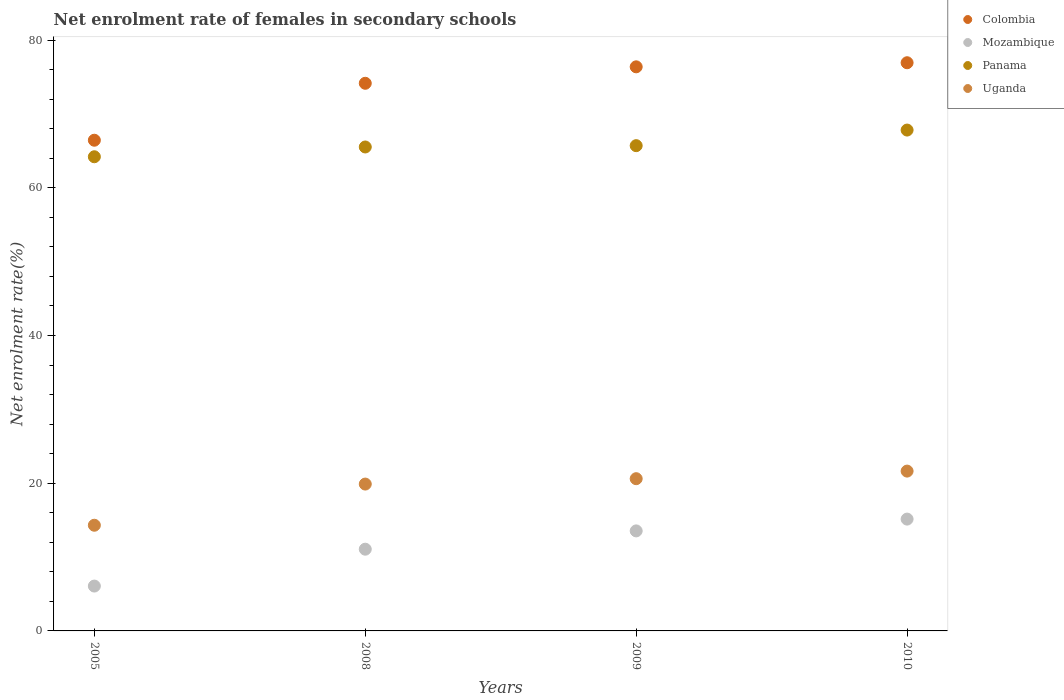How many different coloured dotlines are there?
Your answer should be compact. 4. Is the number of dotlines equal to the number of legend labels?
Offer a very short reply. Yes. What is the net enrolment rate of females in secondary schools in Panama in 2008?
Keep it short and to the point. 65.52. Across all years, what is the maximum net enrolment rate of females in secondary schools in Panama?
Your answer should be very brief. 67.81. Across all years, what is the minimum net enrolment rate of females in secondary schools in Panama?
Your response must be concise. 64.19. In which year was the net enrolment rate of females in secondary schools in Colombia maximum?
Offer a terse response. 2010. In which year was the net enrolment rate of females in secondary schools in Uganda minimum?
Make the answer very short. 2005. What is the total net enrolment rate of females in secondary schools in Mozambique in the graph?
Your answer should be very brief. 45.82. What is the difference between the net enrolment rate of females in secondary schools in Panama in 2005 and that in 2010?
Offer a very short reply. -3.61. What is the difference between the net enrolment rate of females in secondary schools in Colombia in 2009 and the net enrolment rate of females in secondary schools in Panama in 2010?
Your answer should be compact. 8.56. What is the average net enrolment rate of females in secondary schools in Colombia per year?
Provide a short and direct response. 73.47. In the year 2010, what is the difference between the net enrolment rate of females in secondary schools in Mozambique and net enrolment rate of females in secondary schools in Panama?
Ensure brevity in your answer.  -52.67. In how many years, is the net enrolment rate of females in secondary schools in Panama greater than 48 %?
Provide a short and direct response. 4. What is the ratio of the net enrolment rate of females in secondary schools in Panama in 2008 to that in 2010?
Your answer should be compact. 0.97. Is the net enrolment rate of females in secondary schools in Colombia in 2008 less than that in 2009?
Your answer should be compact. Yes. What is the difference between the highest and the second highest net enrolment rate of females in secondary schools in Colombia?
Give a very brief answer. 0.55. What is the difference between the highest and the lowest net enrolment rate of females in secondary schools in Panama?
Your answer should be very brief. 3.61. Is the sum of the net enrolment rate of females in secondary schools in Panama in 2008 and 2009 greater than the maximum net enrolment rate of females in secondary schools in Mozambique across all years?
Your answer should be very brief. Yes. Is it the case that in every year, the sum of the net enrolment rate of females in secondary schools in Uganda and net enrolment rate of females in secondary schools in Panama  is greater than the sum of net enrolment rate of females in secondary schools in Mozambique and net enrolment rate of females in secondary schools in Colombia?
Give a very brief answer. No. Does the net enrolment rate of females in secondary schools in Mozambique monotonically increase over the years?
Offer a terse response. Yes. Is the net enrolment rate of females in secondary schools in Mozambique strictly greater than the net enrolment rate of females in secondary schools in Panama over the years?
Give a very brief answer. No. Is the net enrolment rate of females in secondary schools in Panama strictly less than the net enrolment rate of females in secondary schools in Mozambique over the years?
Offer a terse response. No. How many dotlines are there?
Offer a terse response. 4. How many years are there in the graph?
Keep it short and to the point. 4. Does the graph contain grids?
Make the answer very short. No. How many legend labels are there?
Provide a succinct answer. 4. How are the legend labels stacked?
Your answer should be very brief. Vertical. What is the title of the graph?
Keep it short and to the point. Net enrolment rate of females in secondary schools. What is the label or title of the Y-axis?
Provide a short and direct response. Net enrolment rate(%). What is the Net enrolment rate(%) in Colombia in 2005?
Ensure brevity in your answer.  66.43. What is the Net enrolment rate(%) in Mozambique in 2005?
Keep it short and to the point. 6.07. What is the Net enrolment rate(%) in Panama in 2005?
Give a very brief answer. 64.19. What is the Net enrolment rate(%) of Uganda in 2005?
Your response must be concise. 14.31. What is the Net enrolment rate(%) of Colombia in 2008?
Offer a terse response. 74.14. What is the Net enrolment rate(%) in Mozambique in 2008?
Your answer should be very brief. 11.06. What is the Net enrolment rate(%) of Panama in 2008?
Your response must be concise. 65.52. What is the Net enrolment rate(%) in Uganda in 2008?
Offer a terse response. 19.88. What is the Net enrolment rate(%) in Colombia in 2009?
Offer a very short reply. 76.37. What is the Net enrolment rate(%) in Mozambique in 2009?
Offer a terse response. 13.54. What is the Net enrolment rate(%) of Panama in 2009?
Your answer should be compact. 65.7. What is the Net enrolment rate(%) in Uganda in 2009?
Give a very brief answer. 20.61. What is the Net enrolment rate(%) of Colombia in 2010?
Make the answer very short. 76.92. What is the Net enrolment rate(%) of Mozambique in 2010?
Keep it short and to the point. 15.14. What is the Net enrolment rate(%) of Panama in 2010?
Your answer should be very brief. 67.81. What is the Net enrolment rate(%) in Uganda in 2010?
Ensure brevity in your answer.  21.64. Across all years, what is the maximum Net enrolment rate(%) in Colombia?
Ensure brevity in your answer.  76.92. Across all years, what is the maximum Net enrolment rate(%) in Mozambique?
Offer a terse response. 15.14. Across all years, what is the maximum Net enrolment rate(%) in Panama?
Provide a short and direct response. 67.81. Across all years, what is the maximum Net enrolment rate(%) in Uganda?
Your response must be concise. 21.64. Across all years, what is the minimum Net enrolment rate(%) in Colombia?
Offer a terse response. 66.43. Across all years, what is the minimum Net enrolment rate(%) in Mozambique?
Your answer should be very brief. 6.07. Across all years, what is the minimum Net enrolment rate(%) in Panama?
Provide a short and direct response. 64.19. Across all years, what is the minimum Net enrolment rate(%) of Uganda?
Offer a very short reply. 14.31. What is the total Net enrolment rate(%) in Colombia in the graph?
Provide a succinct answer. 293.86. What is the total Net enrolment rate(%) of Mozambique in the graph?
Your answer should be very brief. 45.82. What is the total Net enrolment rate(%) of Panama in the graph?
Make the answer very short. 263.21. What is the total Net enrolment rate(%) of Uganda in the graph?
Your response must be concise. 76.43. What is the difference between the Net enrolment rate(%) in Colombia in 2005 and that in 2008?
Your answer should be compact. -7.71. What is the difference between the Net enrolment rate(%) in Mozambique in 2005 and that in 2008?
Ensure brevity in your answer.  -4.99. What is the difference between the Net enrolment rate(%) in Panama in 2005 and that in 2008?
Make the answer very short. -1.32. What is the difference between the Net enrolment rate(%) of Uganda in 2005 and that in 2008?
Give a very brief answer. -5.57. What is the difference between the Net enrolment rate(%) of Colombia in 2005 and that in 2009?
Your answer should be very brief. -9.94. What is the difference between the Net enrolment rate(%) in Mozambique in 2005 and that in 2009?
Keep it short and to the point. -7.47. What is the difference between the Net enrolment rate(%) in Panama in 2005 and that in 2009?
Ensure brevity in your answer.  -1.5. What is the difference between the Net enrolment rate(%) in Uganda in 2005 and that in 2009?
Provide a succinct answer. -6.3. What is the difference between the Net enrolment rate(%) of Colombia in 2005 and that in 2010?
Offer a terse response. -10.49. What is the difference between the Net enrolment rate(%) in Mozambique in 2005 and that in 2010?
Ensure brevity in your answer.  -9.07. What is the difference between the Net enrolment rate(%) of Panama in 2005 and that in 2010?
Ensure brevity in your answer.  -3.61. What is the difference between the Net enrolment rate(%) in Uganda in 2005 and that in 2010?
Offer a terse response. -7.33. What is the difference between the Net enrolment rate(%) of Colombia in 2008 and that in 2009?
Keep it short and to the point. -2.23. What is the difference between the Net enrolment rate(%) of Mozambique in 2008 and that in 2009?
Keep it short and to the point. -2.48. What is the difference between the Net enrolment rate(%) of Panama in 2008 and that in 2009?
Your response must be concise. -0.18. What is the difference between the Net enrolment rate(%) in Uganda in 2008 and that in 2009?
Provide a succinct answer. -0.73. What is the difference between the Net enrolment rate(%) of Colombia in 2008 and that in 2010?
Keep it short and to the point. -2.78. What is the difference between the Net enrolment rate(%) of Mozambique in 2008 and that in 2010?
Your answer should be very brief. -4.07. What is the difference between the Net enrolment rate(%) in Panama in 2008 and that in 2010?
Give a very brief answer. -2.29. What is the difference between the Net enrolment rate(%) of Uganda in 2008 and that in 2010?
Your answer should be compact. -1.75. What is the difference between the Net enrolment rate(%) of Colombia in 2009 and that in 2010?
Offer a very short reply. -0.55. What is the difference between the Net enrolment rate(%) in Mozambique in 2009 and that in 2010?
Offer a terse response. -1.6. What is the difference between the Net enrolment rate(%) of Panama in 2009 and that in 2010?
Your answer should be compact. -2.11. What is the difference between the Net enrolment rate(%) in Uganda in 2009 and that in 2010?
Provide a short and direct response. -1.03. What is the difference between the Net enrolment rate(%) in Colombia in 2005 and the Net enrolment rate(%) in Mozambique in 2008?
Your answer should be very brief. 55.37. What is the difference between the Net enrolment rate(%) of Colombia in 2005 and the Net enrolment rate(%) of Panama in 2008?
Provide a short and direct response. 0.92. What is the difference between the Net enrolment rate(%) in Colombia in 2005 and the Net enrolment rate(%) in Uganda in 2008?
Make the answer very short. 46.55. What is the difference between the Net enrolment rate(%) in Mozambique in 2005 and the Net enrolment rate(%) in Panama in 2008?
Make the answer very short. -59.44. What is the difference between the Net enrolment rate(%) in Mozambique in 2005 and the Net enrolment rate(%) in Uganda in 2008?
Offer a very short reply. -13.81. What is the difference between the Net enrolment rate(%) of Panama in 2005 and the Net enrolment rate(%) of Uganda in 2008?
Your answer should be very brief. 44.31. What is the difference between the Net enrolment rate(%) in Colombia in 2005 and the Net enrolment rate(%) in Mozambique in 2009?
Your response must be concise. 52.89. What is the difference between the Net enrolment rate(%) of Colombia in 2005 and the Net enrolment rate(%) of Panama in 2009?
Make the answer very short. 0.74. What is the difference between the Net enrolment rate(%) in Colombia in 2005 and the Net enrolment rate(%) in Uganda in 2009?
Your answer should be very brief. 45.82. What is the difference between the Net enrolment rate(%) of Mozambique in 2005 and the Net enrolment rate(%) of Panama in 2009?
Your answer should be compact. -59.62. What is the difference between the Net enrolment rate(%) of Mozambique in 2005 and the Net enrolment rate(%) of Uganda in 2009?
Provide a succinct answer. -14.54. What is the difference between the Net enrolment rate(%) of Panama in 2005 and the Net enrolment rate(%) of Uganda in 2009?
Your answer should be compact. 43.58. What is the difference between the Net enrolment rate(%) in Colombia in 2005 and the Net enrolment rate(%) in Mozambique in 2010?
Keep it short and to the point. 51.29. What is the difference between the Net enrolment rate(%) in Colombia in 2005 and the Net enrolment rate(%) in Panama in 2010?
Make the answer very short. -1.38. What is the difference between the Net enrolment rate(%) of Colombia in 2005 and the Net enrolment rate(%) of Uganda in 2010?
Offer a very short reply. 44.8. What is the difference between the Net enrolment rate(%) of Mozambique in 2005 and the Net enrolment rate(%) of Panama in 2010?
Keep it short and to the point. -61.73. What is the difference between the Net enrolment rate(%) in Mozambique in 2005 and the Net enrolment rate(%) in Uganda in 2010?
Your response must be concise. -15.56. What is the difference between the Net enrolment rate(%) in Panama in 2005 and the Net enrolment rate(%) in Uganda in 2010?
Your answer should be very brief. 42.56. What is the difference between the Net enrolment rate(%) in Colombia in 2008 and the Net enrolment rate(%) in Mozambique in 2009?
Provide a succinct answer. 60.6. What is the difference between the Net enrolment rate(%) in Colombia in 2008 and the Net enrolment rate(%) in Panama in 2009?
Offer a very short reply. 8.44. What is the difference between the Net enrolment rate(%) in Colombia in 2008 and the Net enrolment rate(%) in Uganda in 2009?
Offer a very short reply. 53.53. What is the difference between the Net enrolment rate(%) in Mozambique in 2008 and the Net enrolment rate(%) in Panama in 2009?
Offer a very short reply. -54.63. What is the difference between the Net enrolment rate(%) of Mozambique in 2008 and the Net enrolment rate(%) of Uganda in 2009?
Offer a terse response. -9.54. What is the difference between the Net enrolment rate(%) of Panama in 2008 and the Net enrolment rate(%) of Uganda in 2009?
Provide a short and direct response. 44.91. What is the difference between the Net enrolment rate(%) in Colombia in 2008 and the Net enrolment rate(%) in Mozambique in 2010?
Ensure brevity in your answer.  59. What is the difference between the Net enrolment rate(%) in Colombia in 2008 and the Net enrolment rate(%) in Panama in 2010?
Your response must be concise. 6.33. What is the difference between the Net enrolment rate(%) of Colombia in 2008 and the Net enrolment rate(%) of Uganda in 2010?
Keep it short and to the point. 52.5. What is the difference between the Net enrolment rate(%) of Mozambique in 2008 and the Net enrolment rate(%) of Panama in 2010?
Give a very brief answer. -56.74. What is the difference between the Net enrolment rate(%) of Mozambique in 2008 and the Net enrolment rate(%) of Uganda in 2010?
Offer a very short reply. -10.57. What is the difference between the Net enrolment rate(%) in Panama in 2008 and the Net enrolment rate(%) in Uganda in 2010?
Ensure brevity in your answer.  43.88. What is the difference between the Net enrolment rate(%) of Colombia in 2009 and the Net enrolment rate(%) of Mozambique in 2010?
Keep it short and to the point. 61.23. What is the difference between the Net enrolment rate(%) in Colombia in 2009 and the Net enrolment rate(%) in Panama in 2010?
Ensure brevity in your answer.  8.56. What is the difference between the Net enrolment rate(%) in Colombia in 2009 and the Net enrolment rate(%) in Uganda in 2010?
Offer a very short reply. 54.73. What is the difference between the Net enrolment rate(%) of Mozambique in 2009 and the Net enrolment rate(%) of Panama in 2010?
Provide a succinct answer. -54.27. What is the difference between the Net enrolment rate(%) in Mozambique in 2009 and the Net enrolment rate(%) in Uganda in 2010?
Your response must be concise. -8.09. What is the difference between the Net enrolment rate(%) in Panama in 2009 and the Net enrolment rate(%) in Uganda in 2010?
Your response must be concise. 44.06. What is the average Net enrolment rate(%) in Colombia per year?
Your response must be concise. 73.47. What is the average Net enrolment rate(%) in Mozambique per year?
Offer a terse response. 11.45. What is the average Net enrolment rate(%) in Panama per year?
Keep it short and to the point. 65.8. What is the average Net enrolment rate(%) in Uganda per year?
Offer a very short reply. 19.11. In the year 2005, what is the difference between the Net enrolment rate(%) of Colombia and Net enrolment rate(%) of Mozambique?
Provide a succinct answer. 60.36. In the year 2005, what is the difference between the Net enrolment rate(%) of Colombia and Net enrolment rate(%) of Panama?
Your answer should be very brief. 2.24. In the year 2005, what is the difference between the Net enrolment rate(%) in Colombia and Net enrolment rate(%) in Uganda?
Offer a very short reply. 52.12. In the year 2005, what is the difference between the Net enrolment rate(%) of Mozambique and Net enrolment rate(%) of Panama?
Ensure brevity in your answer.  -58.12. In the year 2005, what is the difference between the Net enrolment rate(%) in Mozambique and Net enrolment rate(%) in Uganda?
Offer a very short reply. -8.23. In the year 2005, what is the difference between the Net enrolment rate(%) of Panama and Net enrolment rate(%) of Uganda?
Offer a terse response. 49.89. In the year 2008, what is the difference between the Net enrolment rate(%) of Colombia and Net enrolment rate(%) of Mozambique?
Your answer should be very brief. 63.08. In the year 2008, what is the difference between the Net enrolment rate(%) in Colombia and Net enrolment rate(%) in Panama?
Offer a terse response. 8.62. In the year 2008, what is the difference between the Net enrolment rate(%) in Colombia and Net enrolment rate(%) in Uganda?
Your answer should be very brief. 54.26. In the year 2008, what is the difference between the Net enrolment rate(%) of Mozambique and Net enrolment rate(%) of Panama?
Provide a short and direct response. -54.45. In the year 2008, what is the difference between the Net enrolment rate(%) of Mozambique and Net enrolment rate(%) of Uganda?
Provide a short and direct response. -8.82. In the year 2008, what is the difference between the Net enrolment rate(%) of Panama and Net enrolment rate(%) of Uganda?
Give a very brief answer. 45.64. In the year 2009, what is the difference between the Net enrolment rate(%) in Colombia and Net enrolment rate(%) in Mozambique?
Offer a very short reply. 62.83. In the year 2009, what is the difference between the Net enrolment rate(%) of Colombia and Net enrolment rate(%) of Panama?
Give a very brief answer. 10.67. In the year 2009, what is the difference between the Net enrolment rate(%) in Colombia and Net enrolment rate(%) in Uganda?
Offer a terse response. 55.76. In the year 2009, what is the difference between the Net enrolment rate(%) of Mozambique and Net enrolment rate(%) of Panama?
Make the answer very short. -52.15. In the year 2009, what is the difference between the Net enrolment rate(%) of Mozambique and Net enrolment rate(%) of Uganda?
Keep it short and to the point. -7.07. In the year 2009, what is the difference between the Net enrolment rate(%) in Panama and Net enrolment rate(%) in Uganda?
Provide a succinct answer. 45.09. In the year 2010, what is the difference between the Net enrolment rate(%) of Colombia and Net enrolment rate(%) of Mozambique?
Provide a succinct answer. 61.78. In the year 2010, what is the difference between the Net enrolment rate(%) of Colombia and Net enrolment rate(%) of Panama?
Provide a short and direct response. 9.11. In the year 2010, what is the difference between the Net enrolment rate(%) in Colombia and Net enrolment rate(%) in Uganda?
Make the answer very short. 55.29. In the year 2010, what is the difference between the Net enrolment rate(%) in Mozambique and Net enrolment rate(%) in Panama?
Keep it short and to the point. -52.67. In the year 2010, what is the difference between the Net enrolment rate(%) of Mozambique and Net enrolment rate(%) of Uganda?
Give a very brief answer. -6.5. In the year 2010, what is the difference between the Net enrolment rate(%) of Panama and Net enrolment rate(%) of Uganda?
Your response must be concise. 46.17. What is the ratio of the Net enrolment rate(%) in Colombia in 2005 to that in 2008?
Your answer should be compact. 0.9. What is the ratio of the Net enrolment rate(%) of Mozambique in 2005 to that in 2008?
Offer a very short reply. 0.55. What is the ratio of the Net enrolment rate(%) in Panama in 2005 to that in 2008?
Provide a succinct answer. 0.98. What is the ratio of the Net enrolment rate(%) in Uganda in 2005 to that in 2008?
Your answer should be compact. 0.72. What is the ratio of the Net enrolment rate(%) in Colombia in 2005 to that in 2009?
Your response must be concise. 0.87. What is the ratio of the Net enrolment rate(%) of Mozambique in 2005 to that in 2009?
Give a very brief answer. 0.45. What is the ratio of the Net enrolment rate(%) of Panama in 2005 to that in 2009?
Your answer should be compact. 0.98. What is the ratio of the Net enrolment rate(%) in Uganda in 2005 to that in 2009?
Your answer should be compact. 0.69. What is the ratio of the Net enrolment rate(%) in Colombia in 2005 to that in 2010?
Your response must be concise. 0.86. What is the ratio of the Net enrolment rate(%) of Mozambique in 2005 to that in 2010?
Your answer should be compact. 0.4. What is the ratio of the Net enrolment rate(%) in Panama in 2005 to that in 2010?
Provide a succinct answer. 0.95. What is the ratio of the Net enrolment rate(%) of Uganda in 2005 to that in 2010?
Provide a succinct answer. 0.66. What is the ratio of the Net enrolment rate(%) in Colombia in 2008 to that in 2009?
Provide a succinct answer. 0.97. What is the ratio of the Net enrolment rate(%) in Mozambique in 2008 to that in 2009?
Your answer should be very brief. 0.82. What is the ratio of the Net enrolment rate(%) in Uganda in 2008 to that in 2009?
Give a very brief answer. 0.96. What is the ratio of the Net enrolment rate(%) of Colombia in 2008 to that in 2010?
Provide a short and direct response. 0.96. What is the ratio of the Net enrolment rate(%) in Mozambique in 2008 to that in 2010?
Provide a succinct answer. 0.73. What is the ratio of the Net enrolment rate(%) in Panama in 2008 to that in 2010?
Your answer should be very brief. 0.97. What is the ratio of the Net enrolment rate(%) of Uganda in 2008 to that in 2010?
Offer a terse response. 0.92. What is the ratio of the Net enrolment rate(%) of Mozambique in 2009 to that in 2010?
Provide a succinct answer. 0.89. What is the ratio of the Net enrolment rate(%) in Panama in 2009 to that in 2010?
Your answer should be very brief. 0.97. What is the ratio of the Net enrolment rate(%) of Uganda in 2009 to that in 2010?
Ensure brevity in your answer.  0.95. What is the difference between the highest and the second highest Net enrolment rate(%) of Colombia?
Make the answer very short. 0.55. What is the difference between the highest and the second highest Net enrolment rate(%) in Mozambique?
Give a very brief answer. 1.6. What is the difference between the highest and the second highest Net enrolment rate(%) of Panama?
Make the answer very short. 2.11. What is the difference between the highest and the second highest Net enrolment rate(%) of Uganda?
Your answer should be compact. 1.03. What is the difference between the highest and the lowest Net enrolment rate(%) of Colombia?
Your response must be concise. 10.49. What is the difference between the highest and the lowest Net enrolment rate(%) in Mozambique?
Provide a short and direct response. 9.07. What is the difference between the highest and the lowest Net enrolment rate(%) in Panama?
Offer a terse response. 3.61. What is the difference between the highest and the lowest Net enrolment rate(%) in Uganda?
Provide a succinct answer. 7.33. 